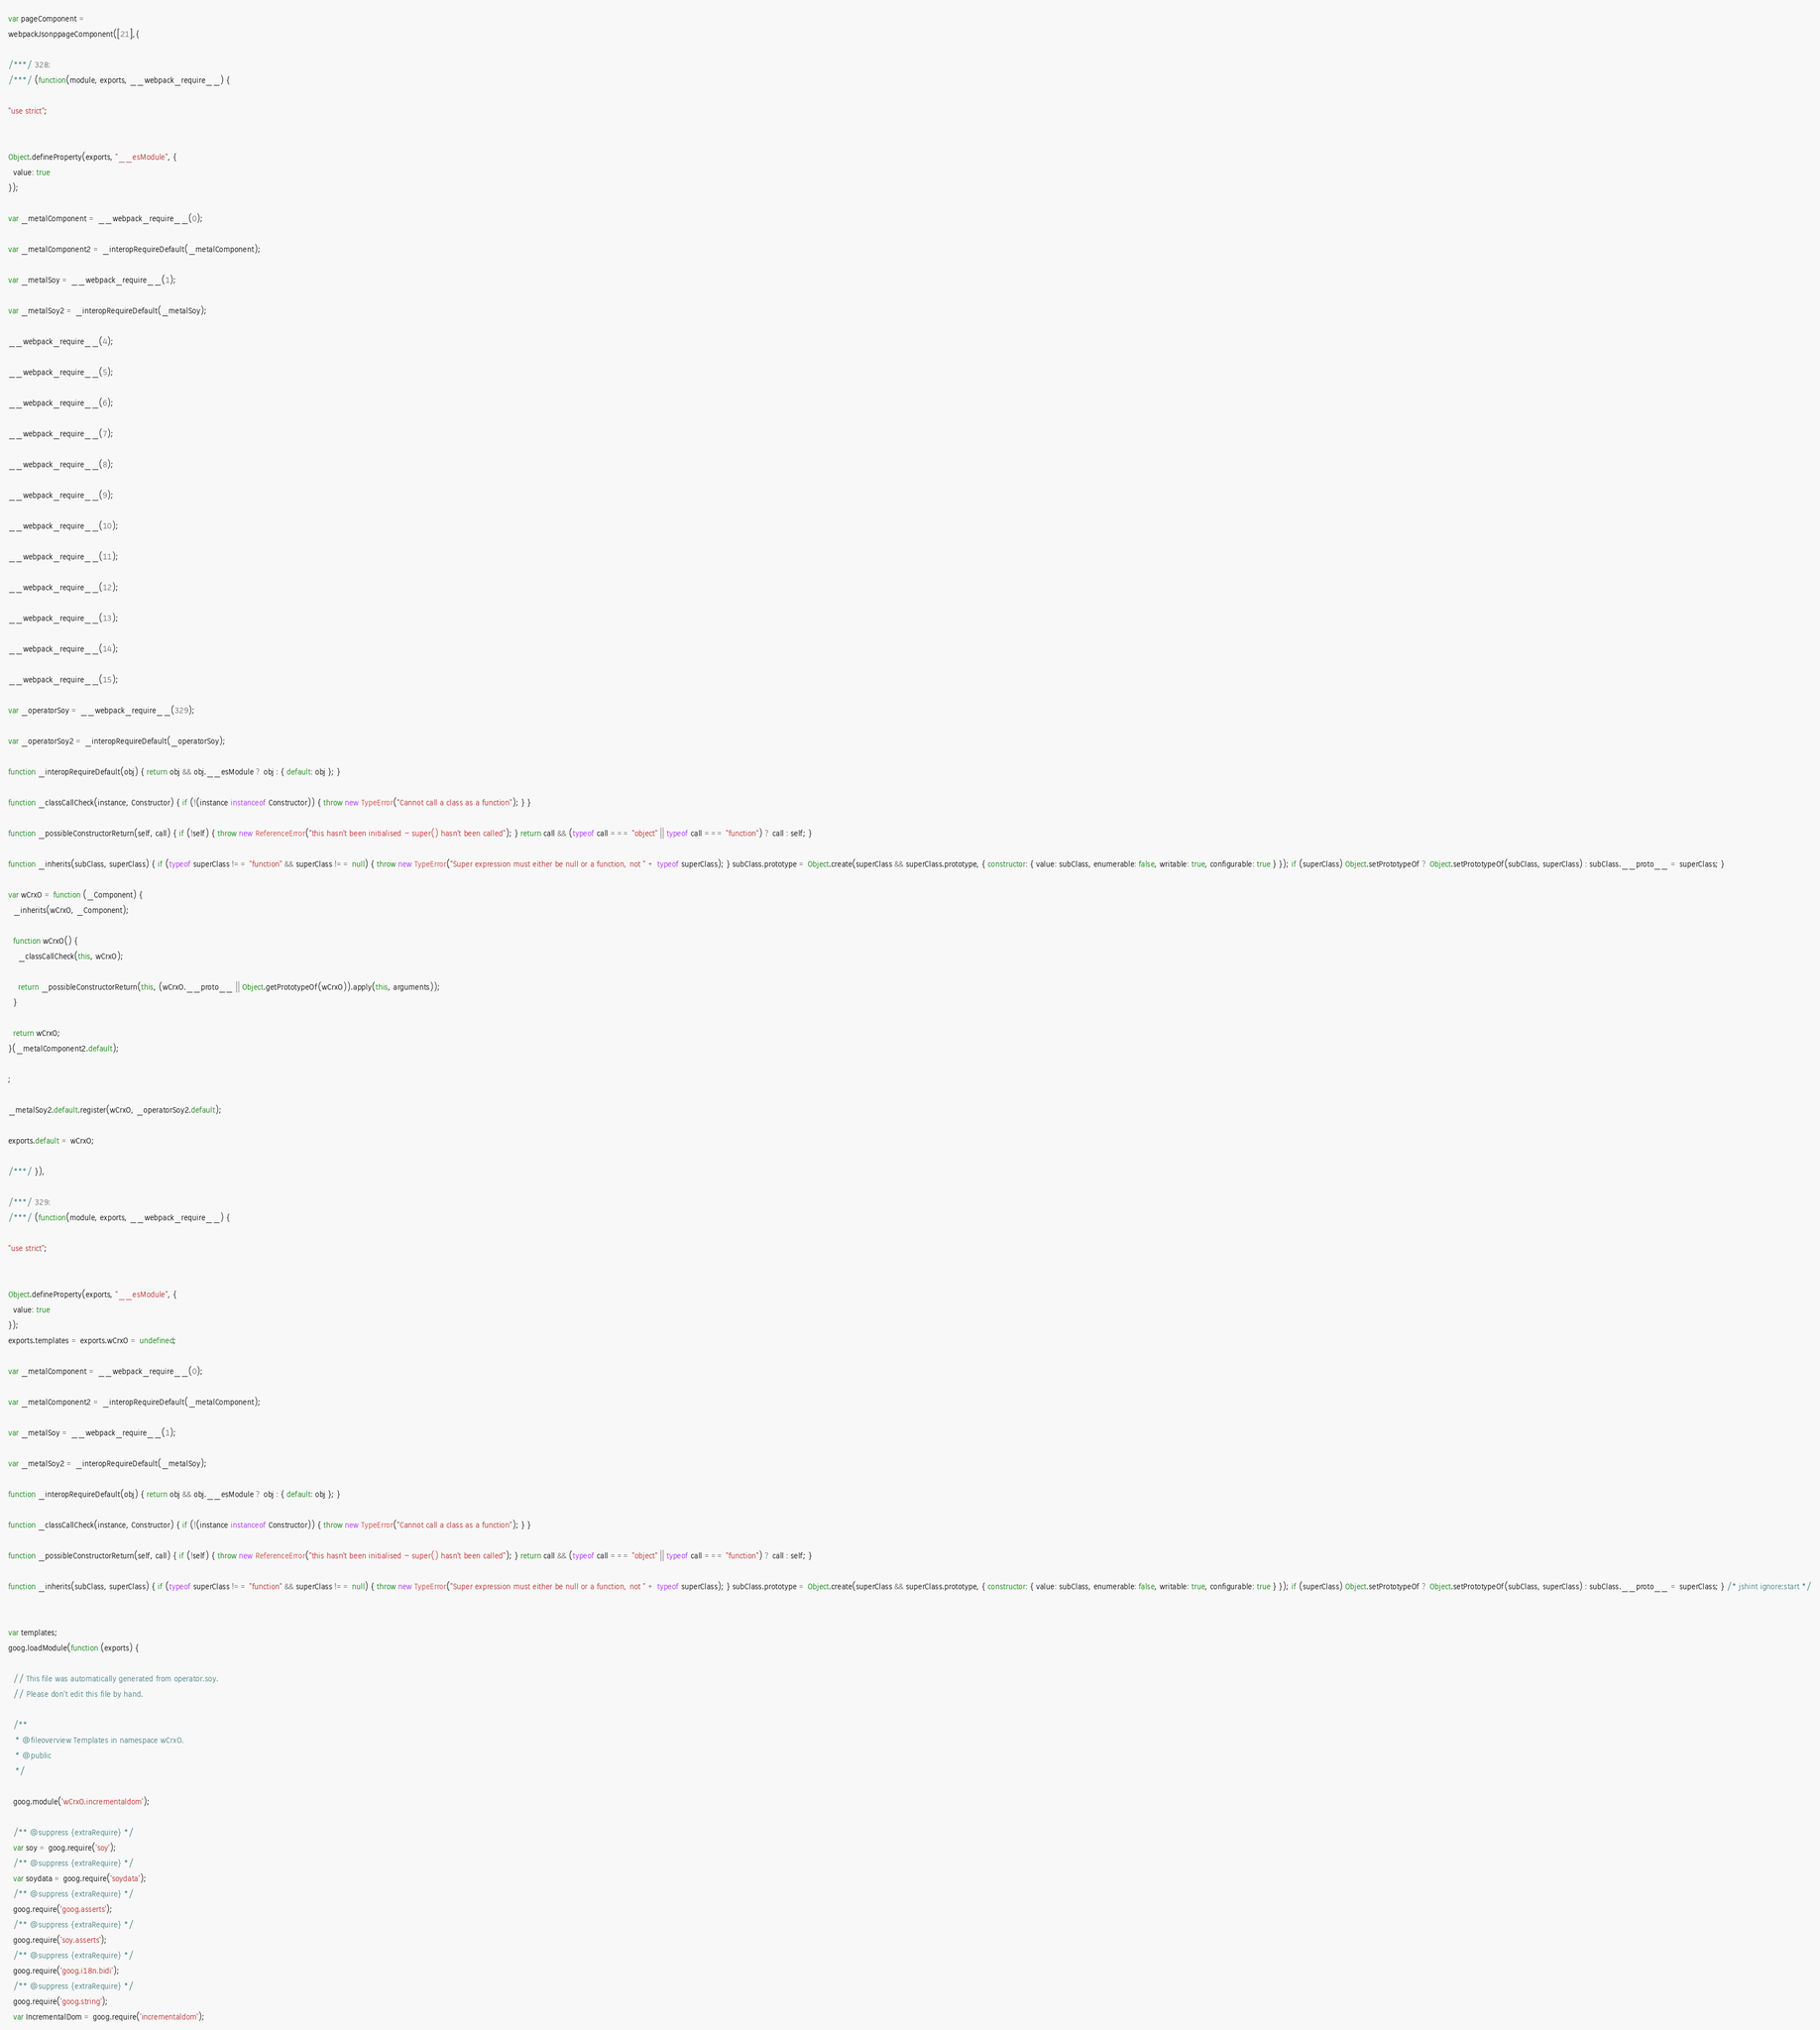Convert code to text. <code><loc_0><loc_0><loc_500><loc_500><_JavaScript_>var pageComponent =
webpackJsonppageComponent([21],{

/***/ 328:
/***/ (function(module, exports, __webpack_require__) {

"use strict";


Object.defineProperty(exports, "__esModule", {
  value: true
});

var _metalComponent = __webpack_require__(0);

var _metalComponent2 = _interopRequireDefault(_metalComponent);

var _metalSoy = __webpack_require__(1);

var _metalSoy2 = _interopRequireDefault(_metalSoy);

__webpack_require__(4);

__webpack_require__(5);

__webpack_require__(6);

__webpack_require__(7);

__webpack_require__(8);

__webpack_require__(9);

__webpack_require__(10);

__webpack_require__(11);

__webpack_require__(12);

__webpack_require__(13);

__webpack_require__(14);

__webpack_require__(15);

var _operatorSoy = __webpack_require__(329);

var _operatorSoy2 = _interopRequireDefault(_operatorSoy);

function _interopRequireDefault(obj) { return obj && obj.__esModule ? obj : { default: obj }; }

function _classCallCheck(instance, Constructor) { if (!(instance instanceof Constructor)) { throw new TypeError("Cannot call a class as a function"); } }

function _possibleConstructorReturn(self, call) { if (!self) { throw new ReferenceError("this hasn't been initialised - super() hasn't been called"); } return call && (typeof call === "object" || typeof call === "function") ? call : self; }

function _inherits(subClass, superClass) { if (typeof superClass !== "function" && superClass !== null) { throw new TypeError("Super expression must either be null or a function, not " + typeof superClass); } subClass.prototype = Object.create(superClass && superClass.prototype, { constructor: { value: subClass, enumerable: false, writable: true, configurable: true } }); if (superClass) Object.setPrototypeOf ? Object.setPrototypeOf(subClass, superClass) : subClass.__proto__ = superClass; }

var wCrxO = function (_Component) {
  _inherits(wCrxO, _Component);

  function wCrxO() {
    _classCallCheck(this, wCrxO);

    return _possibleConstructorReturn(this, (wCrxO.__proto__ || Object.getPrototypeOf(wCrxO)).apply(this, arguments));
  }

  return wCrxO;
}(_metalComponent2.default);

;

_metalSoy2.default.register(wCrxO, _operatorSoy2.default);

exports.default = wCrxO;

/***/ }),

/***/ 329:
/***/ (function(module, exports, __webpack_require__) {

"use strict";


Object.defineProperty(exports, "__esModule", {
  value: true
});
exports.templates = exports.wCrxO = undefined;

var _metalComponent = __webpack_require__(0);

var _metalComponent2 = _interopRequireDefault(_metalComponent);

var _metalSoy = __webpack_require__(1);

var _metalSoy2 = _interopRequireDefault(_metalSoy);

function _interopRequireDefault(obj) { return obj && obj.__esModule ? obj : { default: obj }; }

function _classCallCheck(instance, Constructor) { if (!(instance instanceof Constructor)) { throw new TypeError("Cannot call a class as a function"); } }

function _possibleConstructorReturn(self, call) { if (!self) { throw new ReferenceError("this hasn't been initialised - super() hasn't been called"); } return call && (typeof call === "object" || typeof call === "function") ? call : self; }

function _inherits(subClass, superClass) { if (typeof superClass !== "function" && superClass !== null) { throw new TypeError("Super expression must either be null or a function, not " + typeof superClass); } subClass.prototype = Object.create(superClass && superClass.prototype, { constructor: { value: subClass, enumerable: false, writable: true, configurable: true } }); if (superClass) Object.setPrototypeOf ? Object.setPrototypeOf(subClass, superClass) : subClass.__proto__ = superClass; } /* jshint ignore:start */


var templates;
goog.loadModule(function (exports) {

  // This file was automatically generated from operator.soy.
  // Please don't edit this file by hand.

  /**
   * @fileoverview Templates in namespace wCrxO.
   * @public
   */

  goog.module('wCrxO.incrementaldom');

  /** @suppress {extraRequire} */
  var soy = goog.require('soy');
  /** @suppress {extraRequire} */
  var soydata = goog.require('soydata');
  /** @suppress {extraRequire} */
  goog.require('goog.asserts');
  /** @suppress {extraRequire} */
  goog.require('soy.asserts');
  /** @suppress {extraRequire} */
  goog.require('goog.i18n.bidi');
  /** @suppress {extraRequire} */
  goog.require('goog.string');
  var IncrementalDom = goog.require('incrementaldom');</code> 